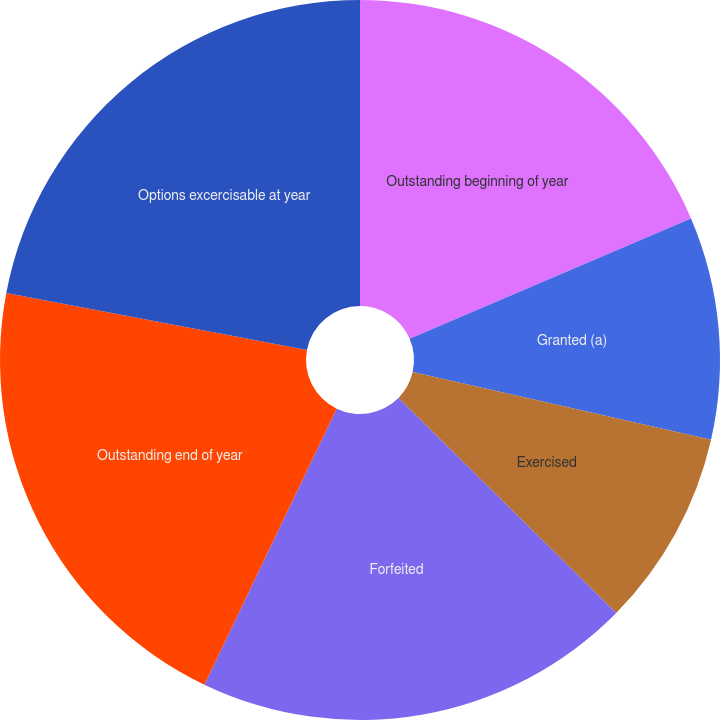Convert chart. <chart><loc_0><loc_0><loc_500><loc_500><pie_chart><fcel>Outstanding beginning of year<fcel>Granted (a)<fcel>Exercised<fcel>Forfeited<fcel>Outstanding end of year<fcel>Options excercisable at year<nl><fcel>18.57%<fcel>9.99%<fcel>8.84%<fcel>19.72%<fcel>20.87%<fcel>22.02%<nl></chart> 